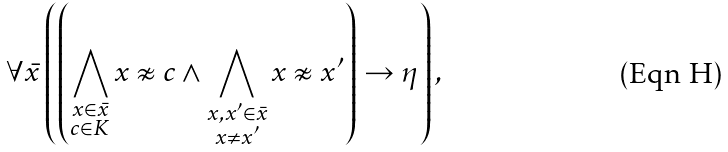Convert formula to latex. <formula><loc_0><loc_0><loc_500><loc_500>\forall \bar { x } \left ( \left ( \bigwedge _ { \substack { x \in \bar { x } \\ c \in K } } x \not \approx c \wedge \bigwedge _ { \substack { x , x ^ { \prime } \in \bar { x } \\ x \neq x ^ { \prime } } } x \not \approx x ^ { \prime } \right ) \rightarrow \eta \right ) ,</formula> 